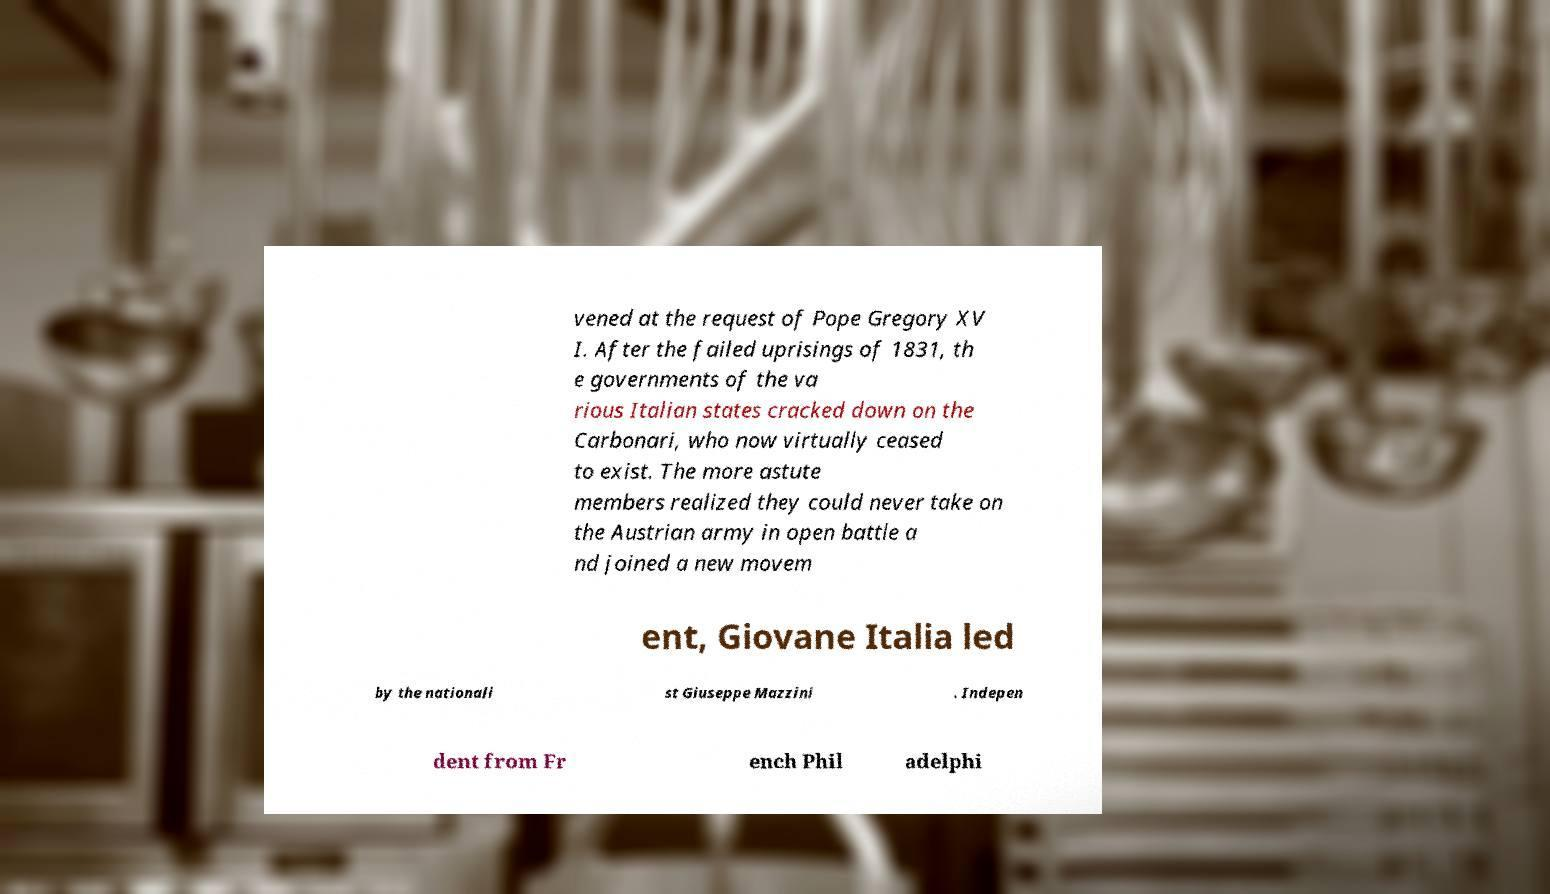There's text embedded in this image that I need extracted. Can you transcribe it verbatim? vened at the request of Pope Gregory XV I. After the failed uprisings of 1831, th e governments of the va rious Italian states cracked down on the Carbonari, who now virtually ceased to exist. The more astute members realized they could never take on the Austrian army in open battle a nd joined a new movem ent, Giovane Italia led by the nationali st Giuseppe Mazzini . Indepen dent from Fr ench Phil adelphi 